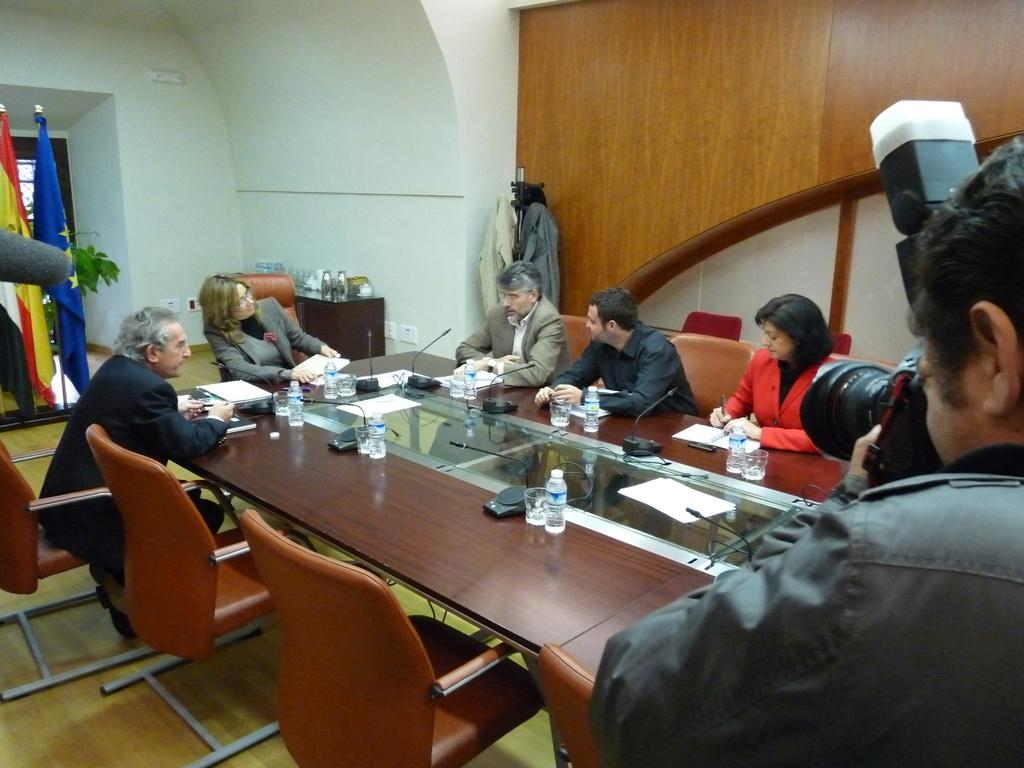What is the man on the right side of the image doing? The man is standing on the right side of the image and taking photographs with a camera. What can be seen on the left side of the image? There are people sitting around a table on the left side of the image. What color is the crayon being used by the man in the image? There is no crayon present in the image; the man is using a camera to take photographs. What type of boundary can be seen separating the man from the people sitting at the table? There is no boundary visible in the image; the man and the people are in different locations within the scene. 